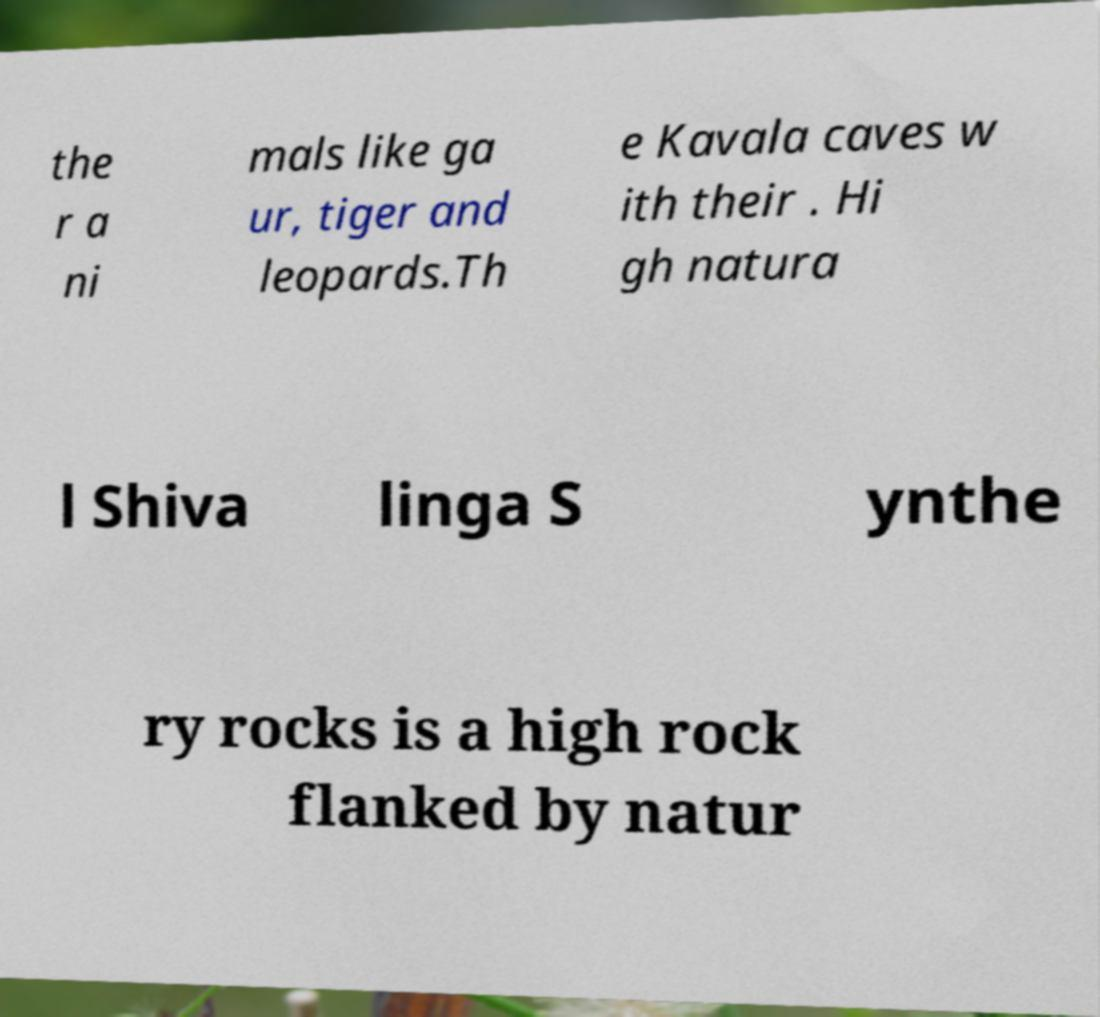Please read and relay the text visible in this image. What does it say? the r a ni mals like ga ur, tiger and leopards.Th e Kavala caves w ith their . Hi gh natura l Shiva linga S ynthe ry rocks is a high rock flanked by natur 